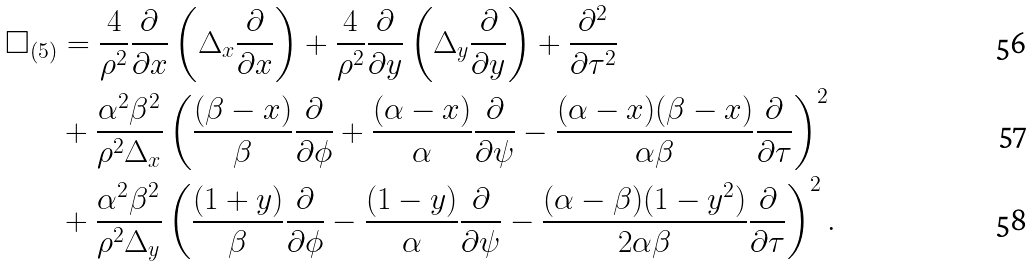<formula> <loc_0><loc_0><loc_500><loc_500>\Box _ { ( 5 ) } & = \frac { 4 } { \rho ^ { 2 } } \frac { \partial } { \partial x } \left ( \Delta _ { x } \frac { \partial } { \partial x } \right ) + \frac { 4 } { \rho ^ { 2 } } \frac { \partial } { \partial y } \left ( \Delta _ { y } \frac { \partial } { \partial y } \right ) + \frac { \partial ^ { 2 } } { \partial \tau ^ { 2 } } \\ & + \frac { \alpha ^ { 2 } \beta ^ { 2 } } { \rho ^ { 2 } \Delta _ { x } } \left ( \frac { ( \beta - x ) } { \beta } \frac { \partial } { \partial \phi } + \frac { ( \alpha - x ) } { \alpha } \frac { \partial } { \partial \psi } - \frac { ( \alpha - x ) ( \beta - x ) } { \alpha \beta } \frac { \partial } { \partial \tau } \right ) ^ { 2 } \\ & + \frac { \alpha ^ { 2 } \beta ^ { 2 } } { \rho ^ { 2 } \Delta _ { y } } \left ( \frac { ( 1 + y ) } { \beta } \frac { \partial } { \partial \phi } - \frac { ( 1 - y ) } { \alpha } \frac { \partial } { \partial \psi } - \frac { ( \alpha - \beta ) ( 1 - y ^ { 2 } ) } { 2 \alpha \beta } \frac { \partial } { \partial \tau } \right ) ^ { 2 } .</formula> 